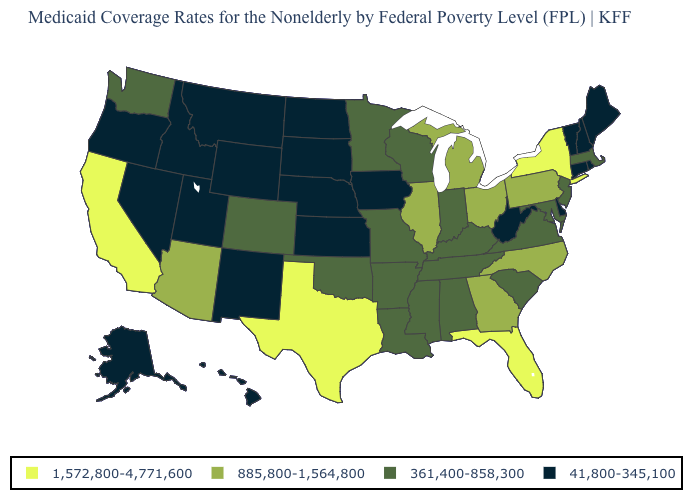Name the states that have a value in the range 1,572,800-4,771,600?
Answer briefly. California, Florida, New York, Texas. What is the value of California?
Answer briefly. 1,572,800-4,771,600. Is the legend a continuous bar?
Short answer required. No. What is the value of Nebraska?
Be succinct. 41,800-345,100. Name the states that have a value in the range 41,800-345,100?
Answer briefly. Alaska, Connecticut, Delaware, Hawaii, Idaho, Iowa, Kansas, Maine, Montana, Nebraska, Nevada, New Hampshire, New Mexico, North Dakota, Oregon, Rhode Island, South Dakota, Utah, Vermont, West Virginia, Wyoming. Does New Jersey have the highest value in the Northeast?
Write a very short answer. No. What is the lowest value in the USA?
Quick response, please. 41,800-345,100. Which states have the lowest value in the Northeast?
Be succinct. Connecticut, Maine, New Hampshire, Rhode Island, Vermont. What is the value of Nevada?
Concise answer only. 41,800-345,100. Name the states that have a value in the range 1,572,800-4,771,600?
Give a very brief answer. California, Florida, New York, Texas. Which states hav the highest value in the South?
Quick response, please. Florida, Texas. What is the value of Illinois?
Be succinct. 885,800-1,564,800. Does Connecticut have the lowest value in the USA?
Be succinct. Yes. What is the highest value in the USA?
Answer briefly. 1,572,800-4,771,600. Name the states that have a value in the range 361,400-858,300?
Be succinct. Alabama, Arkansas, Colorado, Indiana, Kentucky, Louisiana, Maryland, Massachusetts, Minnesota, Mississippi, Missouri, New Jersey, Oklahoma, South Carolina, Tennessee, Virginia, Washington, Wisconsin. 